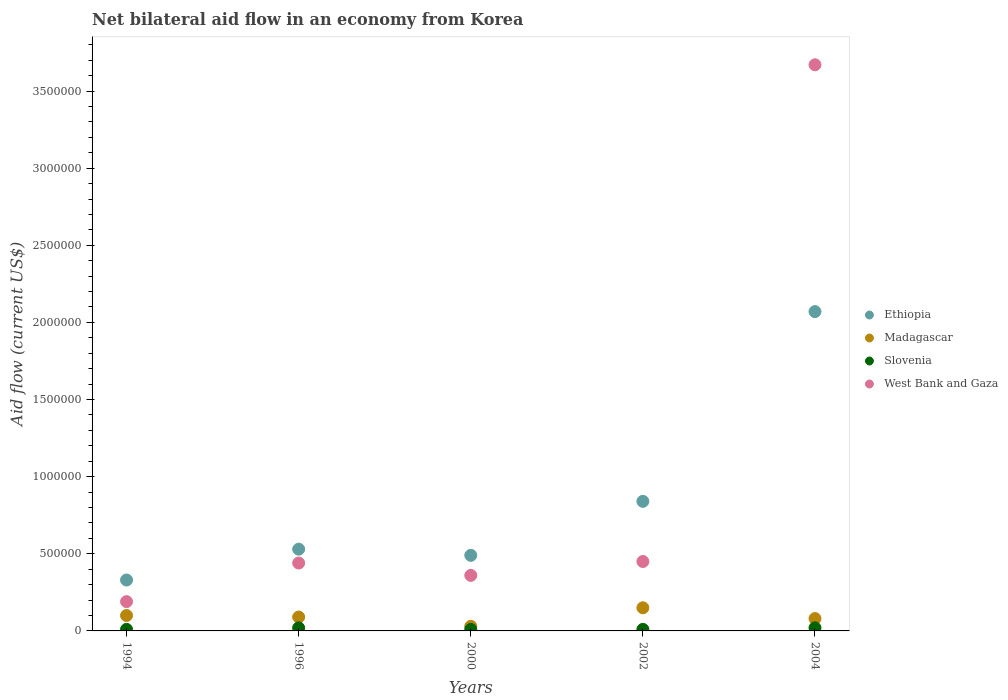How many different coloured dotlines are there?
Offer a very short reply. 4. Is the number of dotlines equal to the number of legend labels?
Offer a terse response. Yes. What is the net bilateral aid flow in Madagascar in 1996?
Keep it short and to the point. 9.00e+04. Across all years, what is the maximum net bilateral aid flow in Slovenia?
Provide a succinct answer. 2.00e+04. Across all years, what is the minimum net bilateral aid flow in Ethiopia?
Offer a terse response. 3.30e+05. What is the total net bilateral aid flow in West Bank and Gaza in the graph?
Provide a short and direct response. 5.11e+06. What is the difference between the net bilateral aid flow in Madagascar in 1996 and that in 2004?
Your answer should be very brief. 10000. What is the average net bilateral aid flow in West Bank and Gaza per year?
Your response must be concise. 1.02e+06. In the year 2004, what is the difference between the net bilateral aid flow in Ethiopia and net bilateral aid flow in Madagascar?
Provide a short and direct response. 1.99e+06. Is the net bilateral aid flow in Slovenia in 1994 less than that in 2004?
Provide a short and direct response. Yes. What is the difference between the highest and the second highest net bilateral aid flow in West Bank and Gaza?
Give a very brief answer. 3.22e+06. What is the difference between the highest and the lowest net bilateral aid flow in West Bank and Gaza?
Keep it short and to the point. 3.48e+06. In how many years, is the net bilateral aid flow in Madagascar greater than the average net bilateral aid flow in Madagascar taken over all years?
Offer a very short reply. 2. Is the sum of the net bilateral aid flow in Madagascar in 1994 and 2002 greater than the maximum net bilateral aid flow in West Bank and Gaza across all years?
Provide a short and direct response. No. Is it the case that in every year, the sum of the net bilateral aid flow in Madagascar and net bilateral aid flow in Ethiopia  is greater than the sum of net bilateral aid flow in Slovenia and net bilateral aid flow in West Bank and Gaza?
Make the answer very short. Yes. Is it the case that in every year, the sum of the net bilateral aid flow in Ethiopia and net bilateral aid flow in West Bank and Gaza  is greater than the net bilateral aid flow in Madagascar?
Keep it short and to the point. Yes. Is the net bilateral aid flow in West Bank and Gaza strictly less than the net bilateral aid flow in Slovenia over the years?
Keep it short and to the point. No. What is the difference between two consecutive major ticks on the Y-axis?
Provide a short and direct response. 5.00e+05. Does the graph contain grids?
Provide a succinct answer. No. Where does the legend appear in the graph?
Your answer should be very brief. Center right. How are the legend labels stacked?
Provide a short and direct response. Vertical. What is the title of the graph?
Offer a terse response. Net bilateral aid flow in an economy from Korea. Does "East Asia (developing only)" appear as one of the legend labels in the graph?
Keep it short and to the point. No. What is the label or title of the X-axis?
Keep it short and to the point. Years. What is the label or title of the Y-axis?
Your response must be concise. Aid flow (current US$). What is the Aid flow (current US$) of Ethiopia in 1994?
Provide a succinct answer. 3.30e+05. What is the Aid flow (current US$) of Slovenia in 1994?
Your answer should be compact. 10000. What is the Aid flow (current US$) of West Bank and Gaza in 1994?
Give a very brief answer. 1.90e+05. What is the Aid flow (current US$) in Ethiopia in 1996?
Provide a succinct answer. 5.30e+05. What is the Aid flow (current US$) in Madagascar in 1996?
Ensure brevity in your answer.  9.00e+04. What is the Aid flow (current US$) of Slovenia in 1996?
Your answer should be compact. 2.00e+04. What is the Aid flow (current US$) in West Bank and Gaza in 2000?
Make the answer very short. 3.60e+05. What is the Aid flow (current US$) in Ethiopia in 2002?
Offer a very short reply. 8.40e+05. What is the Aid flow (current US$) of Ethiopia in 2004?
Give a very brief answer. 2.07e+06. What is the Aid flow (current US$) of West Bank and Gaza in 2004?
Offer a very short reply. 3.67e+06. Across all years, what is the maximum Aid flow (current US$) of Ethiopia?
Provide a short and direct response. 2.07e+06. Across all years, what is the maximum Aid flow (current US$) in Madagascar?
Offer a terse response. 1.50e+05. Across all years, what is the maximum Aid flow (current US$) of Slovenia?
Your answer should be very brief. 2.00e+04. Across all years, what is the maximum Aid flow (current US$) in West Bank and Gaza?
Ensure brevity in your answer.  3.67e+06. Across all years, what is the minimum Aid flow (current US$) of Ethiopia?
Make the answer very short. 3.30e+05. Across all years, what is the minimum Aid flow (current US$) in Slovenia?
Provide a short and direct response. 10000. Across all years, what is the minimum Aid flow (current US$) in West Bank and Gaza?
Offer a terse response. 1.90e+05. What is the total Aid flow (current US$) in Ethiopia in the graph?
Provide a short and direct response. 4.26e+06. What is the total Aid flow (current US$) of Madagascar in the graph?
Give a very brief answer. 4.50e+05. What is the total Aid flow (current US$) of Slovenia in the graph?
Your answer should be compact. 7.00e+04. What is the total Aid flow (current US$) in West Bank and Gaza in the graph?
Give a very brief answer. 5.11e+06. What is the difference between the Aid flow (current US$) in Ethiopia in 1994 and that in 2000?
Offer a terse response. -1.60e+05. What is the difference between the Aid flow (current US$) in Ethiopia in 1994 and that in 2002?
Your answer should be compact. -5.10e+05. What is the difference between the Aid flow (current US$) of Slovenia in 1994 and that in 2002?
Your answer should be very brief. 0. What is the difference between the Aid flow (current US$) of West Bank and Gaza in 1994 and that in 2002?
Provide a succinct answer. -2.60e+05. What is the difference between the Aid flow (current US$) in Ethiopia in 1994 and that in 2004?
Your answer should be compact. -1.74e+06. What is the difference between the Aid flow (current US$) of Madagascar in 1994 and that in 2004?
Provide a succinct answer. 2.00e+04. What is the difference between the Aid flow (current US$) in Slovenia in 1994 and that in 2004?
Offer a very short reply. -10000. What is the difference between the Aid flow (current US$) of West Bank and Gaza in 1994 and that in 2004?
Your answer should be very brief. -3.48e+06. What is the difference between the Aid flow (current US$) in Ethiopia in 1996 and that in 2000?
Your answer should be compact. 4.00e+04. What is the difference between the Aid flow (current US$) of Slovenia in 1996 and that in 2000?
Keep it short and to the point. 10000. What is the difference between the Aid flow (current US$) of West Bank and Gaza in 1996 and that in 2000?
Give a very brief answer. 8.00e+04. What is the difference between the Aid flow (current US$) of Ethiopia in 1996 and that in 2002?
Keep it short and to the point. -3.10e+05. What is the difference between the Aid flow (current US$) in West Bank and Gaza in 1996 and that in 2002?
Your response must be concise. -10000. What is the difference between the Aid flow (current US$) in Ethiopia in 1996 and that in 2004?
Offer a terse response. -1.54e+06. What is the difference between the Aid flow (current US$) in Madagascar in 1996 and that in 2004?
Provide a succinct answer. 10000. What is the difference between the Aid flow (current US$) in Slovenia in 1996 and that in 2004?
Keep it short and to the point. 0. What is the difference between the Aid flow (current US$) in West Bank and Gaza in 1996 and that in 2004?
Offer a terse response. -3.23e+06. What is the difference between the Aid flow (current US$) in Ethiopia in 2000 and that in 2002?
Provide a succinct answer. -3.50e+05. What is the difference between the Aid flow (current US$) in Madagascar in 2000 and that in 2002?
Your answer should be very brief. -1.20e+05. What is the difference between the Aid flow (current US$) of West Bank and Gaza in 2000 and that in 2002?
Ensure brevity in your answer.  -9.00e+04. What is the difference between the Aid flow (current US$) in Ethiopia in 2000 and that in 2004?
Provide a short and direct response. -1.58e+06. What is the difference between the Aid flow (current US$) of Madagascar in 2000 and that in 2004?
Ensure brevity in your answer.  -5.00e+04. What is the difference between the Aid flow (current US$) of West Bank and Gaza in 2000 and that in 2004?
Ensure brevity in your answer.  -3.31e+06. What is the difference between the Aid flow (current US$) of Ethiopia in 2002 and that in 2004?
Keep it short and to the point. -1.23e+06. What is the difference between the Aid flow (current US$) in Madagascar in 2002 and that in 2004?
Your response must be concise. 7.00e+04. What is the difference between the Aid flow (current US$) of Slovenia in 2002 and that in 2004?
Keep it short and to the point. -10000. What is the difference between the Aid flow (current US$) of West Bank and Gaza in 2002 and that in 2004?
Provide a short and direct response. -3.22e+06. What is the difference between the Aid flow (current US$) of Ethiopia in 1994 and the Aid flow (current US$) of Madagascar in 1996?
Keep it short and to the point. 2.40e+05. What is the difference between the Aid flow (current US$) of Madagascar in 1994 and the Aid flow (current US$) of Slovenia in 1996?
Your answer should be compact. 8.00e+04. What is the difference between the Aid flow (current US$) in Madagascar in 1994 and the Aid flow (current US$) in West Bank and Gaza in 1996?
Offer a very short reply. -3.40e+05. What is the difference between the Aid flow (current US$) in Slovenia in 1994 and the Aid flow (current US$) in West Bank and Gaza in 1996?
Provide a succinct answer. -4.30e+05. What is the difference between the Aid flow (current US$) in Ethiopia in 1994 and the Aid flow (current US$) in Madagascar in 2000?
Your answer should be compact. 3.00e+05. What is the difference between the Aid flow (current US$) in Ethiopia in 1994 and the Aid flow (current US$) in West Bank and Gaza in 2000?
Ensure brevity in your answer.  -3.00e+04. What is the difference between the Aid flow (current US$) in Madagascar in 1994 and the Aid flow (current US$) in West Bank and Gaza in 2000?
Provide a succinct answer. -2.60e+05. What is the difference between the Aid flow (current US$) of Slovenia in 1994 and the Aid flow (current US$) of West Bank and Gaza in 2000?
Keep it short and to the point. -3.50e+05. What is the difference between the Aid flow (current US$) in Ethiopia in 1994 and the Aid flow (current US$) in Madagascar in 2002?
Ensure brevity in your answer.  1.80e+05. What is the difference between the Aid flow (current US$) of Ethiopia in 1994 and the Aid flow (current US$) of Slovenia in 2002?
Offer a very short reply. 3.20e+05. What is the difference between the Aid flow (current US$) of Ethiopia in 1994 and the Aid flow (current US$) of West Bank and Gaza in 2002?
Your answer should be very brief. -1.20e+05. What is the difference between the Aid flow (current US$) of Madagascar in 1994 and the Aid flow (current US$) of West Bank and Gaza in 2002?
Provide a succinct answer. -3.50e+05. What is the difference between the Aid flow (current US$) in Slovenia in 1994 and the Aid flow (current US$) in West Bank and Gaza in 2002?
Offer a terse response. -4.40e+05. What is the difference between the Aid flow (current US$) in Ethiopia in 1994 and the Aid flow (current US$) in Madagascar in 2004?
Make the answer very short. 2.50e+05. What is the difference between the Aid flow (current US$) in Ethiopia in 1994 and the Aid flow (current US$) in West Bank and Gaza in 2004?
Offer a terse response. -3.34e+06. What is the difference between the Aid flow (current US$) in Madagascar in 1994 and the Aid flow (current US$) in West Bank and Gaza in 2004?
Keep it short and to the point. -3.57e+06. What is the difference between the Aid flow (current US$) of Slovenia in 1994 and the Aid flow (current US$) of West Bank and Gaza in 2004?
Your response must be concise. -3.66e+06. What is the difference between the Aid flow (current US$) of Ethiopia in 1996 and the Aid flow (current US$) of Slovenia in 2000?
Make the answer very short. 5.20e+05. What is the difference between the Aid flow (current US$) in Madagascar in 1996 and the Aid flow (current US$) in Slovenia in 2000?
Offer a very short reply. 8.00e+04. What is the difference between the Aid flow (current US$) of Slovenia in 1996 and the Aid flow (current US$) of West Bank and Gaza in 2000?
Provide a succinct answer. -3.40e+05. What is the difference between the Aid flow (current US$) of Ethiopia in 1996 and the Aid flow (current US$) of Slovenia in 2002?
Offer a terse response. 5.20e+05. What is the difference between the Aid flow (current US$) in Ethiopia in 1996 and the Aid flow (current US$) in West Bank and Gaza in 2002?
Provide a succinct answer. 8.00e+04. What is the difference between the Aid flow (current US$) of Madagascar in 1996 and the Aid flow (current US$) of West Bank and Gaza in 2002?
Your answer should be compact. -3.60e+05. What is the difference between the Aid flow (current US$) of Slovenia in 1996 and the Aid flow (current US$) of West Bank and Gaza in 2002?
Provide a succinct answer. -4.30e+05. What is the difference between the Aid flow (current US$) of Ethiopia in 1996 and the Aid flow (current US$) of Madagascar in 2004?
Ensure brevity in your answer.  4.50e+05. What is the difference between the Aid flow (current US$) of Ethiopia in 1996 and the Aid flow (current US$) of Slovenia in 2004?
Keep it short and to the point. 5.10e+05. What is the difference between the Aid flow (current US$) of Ethiopia in 1996 and the Aid flow (current US$) of West Bank and Gaza in 2004?
Your answer should be very brief. -3.14e+06. What is the difference between the Aid flow (current US$) of Madagascar in 1996 and the Aid flow (current US$) of West Bank and Gaza in 2004?
Ensure brevity in your answer.  -3.58e+06. What is the difference between the Aid flow (current US$) in Slovenia in 1996 and the Aid flow (current US$) in West Bank and Gaza in 2004?
Your answer should be compact. -3.65e+06. What is the difference between the Aid flow (current US$) of Ethiopia in 2000 and the Aid flow (current US$) of West Bank and Gaza in 2002?
Offer a very short reply. 4.00e+04. What is the difference between the Aid flow (current US$) of Madagascar in 2000 and the Aid flow (current US$) of West Bank and Gaza in 2002?
Provide a succinct answer. -4.20e+05. What is the difference between the Aid flow (current US$) in Slovenia in 2000 and the Aid flow (current US$) in West Bank and Gaza in 2002?
Provide a succinct answer. -4.40e+05. What is the difference between the Aid flow (current US$) in Ethiopia in 2000 and the Aid flow (current US$) in West Bank and Gaza in 2004?
Offer a very short reply. -3.18e+06. What is the difference between the Aid flow (current US$) in Madagascar in 2000 and the Aid flow (current US$) in West Bank and Gaza in 2004?
Give a very brief answer. -3.64e+06. What is the difference between the Aid flow (current US$) of Slovenia in 2000 and the Aid flow (current US$) of West Bank and Gaza in 2004?
Provide a short and direct response. -3.66e+06. What is the difference between the Aid flow (current US$) of Ethiopia in 2002 and the Aid flow (current US$) of Madagascar in 2004?
Keep it short and to the point. 7.60e+05. What is the difference between the Aid flow (current US$) of Ethiopia in 2002 and the Aid flow (current US$) of Slovenia in 2004?
Keep it short and to the point. 8.20e+05. What is the difference between the Aid flow (current US$) of Ethiopia in 2002 and the Aid flow (current US$) of West Bank and Gaza in 2004?
Make the answer very short. -2.83e+06. What is the difference between the Aid flow (current US$) of Madagascar in 2002 and the Aid flow (current US$) of Slovenia in 2004?
Offer a very short reply. 1.30e+05. What is the difference between the Aid flow (current US$) of Madagascar in 2002 and the Aid flow (current US$) of West Bank and Gaza in 2004?
Your answer should be very brief. -3.52e+06. What is the difference between the Aid flow (current US$) of Slovenia in 2002 and the Aid flow (current US$) of West Bank and Gaza in 2004?
Your answer should be very brief. -3.66e+06. What is the average Aid flow (current US$) in Ethiopia per year?
Provide a short and direct response. 8.52e+05. What is the average Aid flow (current US$) of Slovenia per year?
Make the answer very short. 1.40e+04. What is the average Aid flow (current US$) of West Bank and Gaza per year?
Offer a terse response. 1.02e+06. In the year 1994, what is the difference between the Aid flow (current US$) of Ethiopia and Aid flow (current US$) of Madagascar?
Offer a terse response. 2.30e+05. In the year 1994, what is the difference between the Aid flow (current US$) in Ethiopia and Aid flow (current US$) in Slovenia?
Offer a terse response. 3.20e+05. In the year 1994, what is the difference between the Aid flow (current US$) of Madagascar and Aid flow (current US$) of Slovenia?
Provide a short and direct response. 9.00e+04. In the year 1996, what is the difference between the Aid flow (current US$) in Ethiopia and Aid flow (current US$) in Slovenia?
Your response must be concise. 5.10e+05. In the year 1996, what is the difference between the Aid flow (current US$) in Madagascar and Aid flow (current US$) in Slovenia?
Provide a succinct answer. 7.00e+04. In the year 1996, what is the difference between the Aid flow (current US$) of Madagascar and Aid flow (current US$) of West Bank and Gaza?
Give a very brief answer. -3.50e+05. In the year 1996, what is the difference between the Aid flow (current US$) of Slovenia and Aid flow (current US$) of West Bank and Gaza?
Provide a succinct answer. -4.20e+05. In the year 2000, what is the difference between the Aid flow (current US$) of Madagascar and Aid flow (current US$) of Slovenia?
Your answer should be very brief. 2.00e+04. In the year 2000, what is the difference between the Aid flow (current US$) in Madagascar and Aid flow (current US$) in West Bank and Gaza?
Your answer should be very brief. -3.30e+05. In the year 2000, what is the difference between the Aid flow (current US$) of Slovenia and Aid flow (current US$) of West Bank and Gaza?
Offer a terse response. -3.50e+05. In the year 2002, what is the difference between the Aid flow (current US$) of Ethiopia and Aid flow (current US$) of Madagascar?
Your response must be concise. 6.90e+05. In the year 2002, what is the difference between the Aid flow (current US$) of Ethiopia and Aid flow (current US$) of Slovenia?
Your answer should be very brief. 8.30e+05. In the year 2002, what is the difference between the Aid flow (current US$) in Ethiopia and Aid flow (current US$) in West Bank and Gaza?
Provide a succinct answer. 3.90e+05. In the year 2002, what is the difference between the Aid flow (current US$) in Madagascar and Aid flow (current US$) in Slovenia?
Provide a short and direct response. 1.40e+05. In the year 2002, what is the difference between the Aid flow (current US$) of Madagascar and Aid flow (current US$) of West Bank and Gaza?
Your answer should be compact. -3.00e+05. In the year 2002, what is the difference between the Aid flow (current US$) of Slovenia and Aid flow (current US$) of West Bank and Gaza?
Your answer should be very brief. -4.40e+05. In the year 2004, what is the difference between the Aid flow (current US$) in Ethiopia and Aid flow (current US$) in Madagascar?
Offer a terse response. 1.99e+06. In the year 2004, what is the difference between the Aid flow (current US$) in Ethiopia and Aid flow (current US$) in Slovenia?
Keep it short and to the point. 2.05e+06. In the year 2004, what is the difference between the Aid flow (current US$) in Ethiopia and Aid flow (current US$) in West Bank and Gaza?
Offer a terse response. -1.60e+06. In the year 2004, what is the difference between the Aid flow (current US$) of Madagascar and Aid flow (current US$) of Slovenia?
Offer a very short reply. 6.00e+04. In the year 2004, what is the difference between the Aid flow (current US$) in Madagascar and Aid flow (current US$) in West Bank and Gaza?
Keep it short and to the point. -3.59e+06. In the year 2004, what is the difference between the Aid flow (current US$) in Slovenia and Aid flow (current US$) in West Bank and Gaza?
Make the answer very short. -3.65e+06. What is the ratio of the Aid flow (current US$) of Ethiopia in 1994 to that in 1996?
Your response must be concise. 0.62. What is the ratio of the Aid flow (current US$) of West Bank and Gaza in 1994 to that in 1996?
Offer a terse response. 0.43. What is the ratio of the Aid flow (current US$) in Ethiopia in 1994 to that in 2000?
Your answer should be very brief. 0.67. What is the ratio of the Aid flow (current US$) in Slovenia in 1994 to that in 2000?
Provide a succinct answer. 1. What is the ratio of the Aid flow (current US$) of West Bank and Gaza in 1994 to that in 2000?
Your answer should be very brief. 0.53. What is the ratio of the Aid flow (current US$) in Ethiopia in 1994 to that in 2002?
Offer a terse response. 0.39. What is the ratio of the Aid flow (current US$) of Madagascar in 1994 to that in 2002?
Provide a succinct answer. 0.67. What is the ratio of the Aid flow (current US$) of Slovenia in 1994 to that in 2002?
Give a very brief answer. 1. What is the ratio of the Aid flow (current US$) in West Bank and Gaza in 1994 to that in 2002?
Your response must be concise. 0.42. What is the ratio of the Aid flow (current US$) of Ethiopia in 1994 to that in 2004?
Offer a terse response. 0.16. What is the ratio of the Aid flow (current US$) in Madagascar in 1994 to that in 2004?
Make the answer very short. 1.25. What is the ratio of the Aid flow (current US$) in Slovenia in 1994 to that in 2004?
Ensure brevity in your answer.  0.5. What is the ratio of the Aid flow (current US$) of West Bank and Gaza in 1994 to that in 2004?
Make the answer very short. 0.05. What is the ratio of the Aid flow (current US$) in Ethiopia in 1996 to that in 2000?
Offer a terse response. 1.08. What is the ratio of the Aid flow (current US$) in Slovenia in 1996 to that in 2000?
Your answer should be compact. 2. What is the ratio of the Aid flow (current US$) of West Bank and Gaza in 1996 to that in 2000?
Make the answer very short. 1.22. What is the ratio of the Aid flow (current US$) in Ethiopia in 1996 to that in 2002?
Your response must be concise. 0.63. What is the ratio of the Aid flow (current US$) of Slovenia in 1996 to that in 2002?
Offer a very short reply. 2. What is the ratio of the Aid flow (current US$) of West Bank and Gaza in 1996 to that in 2002?
Your response must be concise. 0.98. What is the ratio of the Aid flow (current US$) in Ethiopia in 1996 to that in 2004?
Your answer should be very brief. 0.26. What is the ratio of the Aid flow (current US$) of West Bank and Gaza in 1996 to that in 2004?
Offer a very short reply. 0.12. What is the ratio of the Aid flow (current US$) in Ethiopia in 2000 to that in 2002?
Your response must be concise. 0.58. What is the ratio of the Aid flow (current US$) in Madagascar in 2000 to that in 2002?
Your answer should be very brief. 0.2. What is the ratio of the Aid flow (current US$) in Ethiopia in 2000 to that in 2004?
Your response must be concise. 0.24. What is the ratio of the Aid flow (current US$) of Slovenia in 2000 to that in 2004?
Offer a terse response. 0.5. What is the ratio of the Aid flow (current US$) of West Bank and Gaza in 2000 to that in 2004?
Offer a terse response. 0.1. What is the ratio of the Aid flow (current US$) in Ethiopia in 2002 to that in 2004?
Offer a very short reply. 0.41. What is the ratio of the Aid flow (current US$) in Madagascar in 2002 to that in 2004?
Make the answer very short. 1.88. What is the ratio of the Aid flow (current US$) of Slovenia in 2002 to that in 2004?
Make the answer very short. 0.5. What is the ratio of the Aid flow (current US$) of West Bank and Gaza in 2002 to that in 2004?
Ensure brevity in your answer.  0.12. What is the difference between the highest and the second highest Aid flow (current US$) in Ethiopia?
Provide a short and direct response. 1.23e+06. What is the difference between the highest and the second highest Aid flow (current US$) of Madagascar?
Make the answer very short. 5.00e+04. What is the difference between the highest and the second highest Aid flow (current US$) of Slovenia?
Give a very brief answer. 0. What is the difference between the highest and the second highest Aid flow (current US$) in West Bank and Gaza?
Give a very brief answer. 3.22e+06. What is the difference between the highest and the lowest Aid flow (current US$) of Ethiopia?
Your answer should be compact. 1.74e+06. What is the difference between the highest and the lowest Aid flow (current US$) in West Bank and Gaza?
Ensure brevity in your answer.  3.48e+06. 